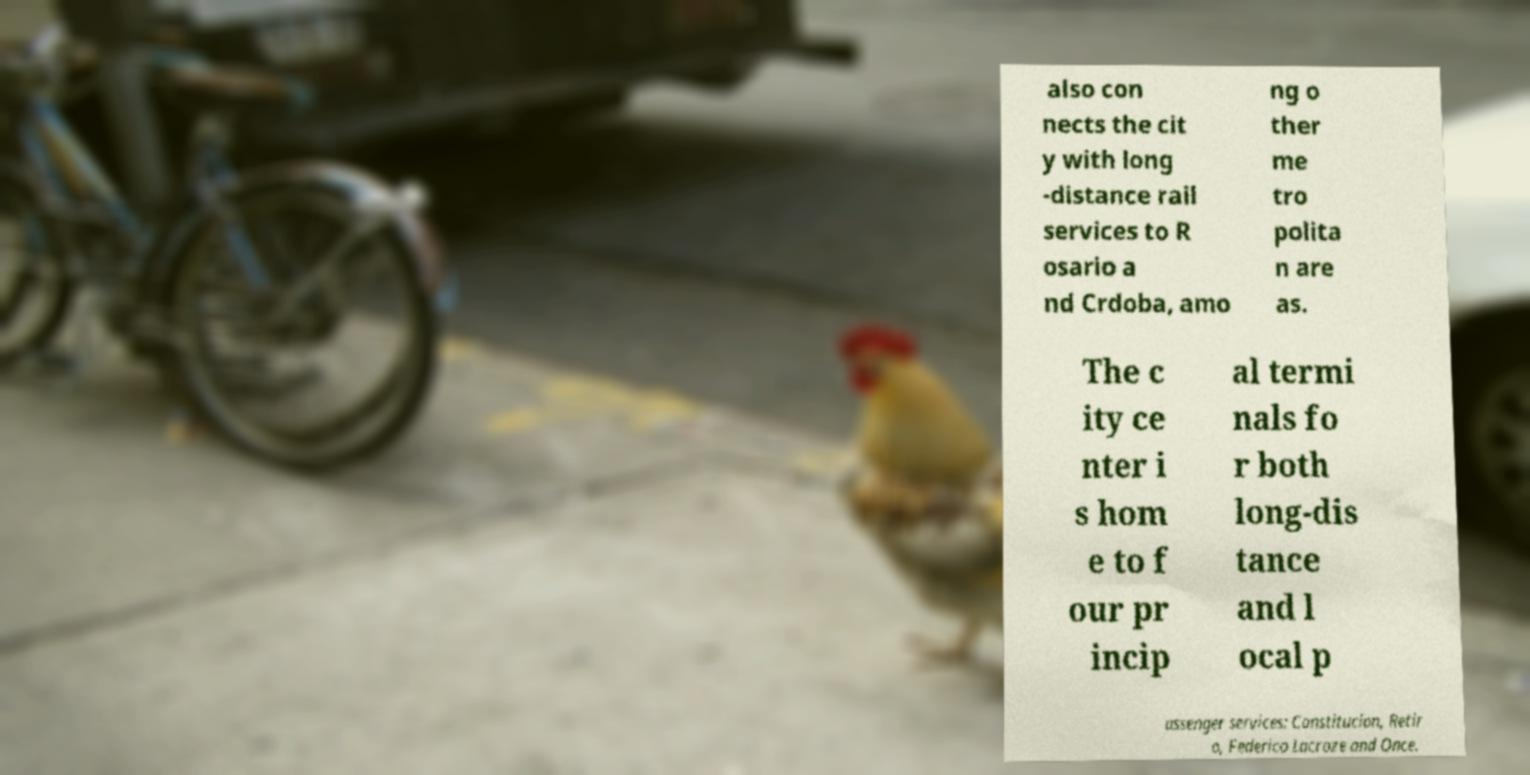What messages or text are displayed in this image? I need them in a readable, typed format. also con nects the cit y with long -distance rail services to R osario a nd Crdoba, amo ng o ther me tro polita n are as. The c ity ce nter i s hom e to f our pr incip al termi nals fo r both long-dis tance and l ocal p assenger services: Constitucion, Retir o, Federico Lacroze and Once. 